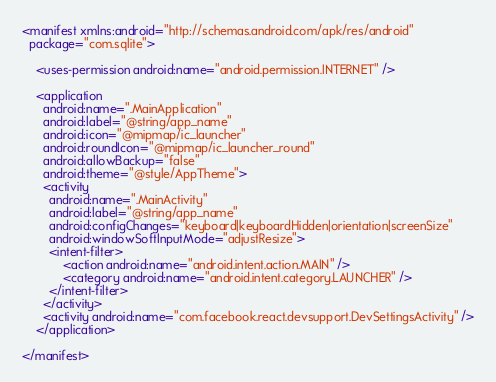Convert code to text. <code><loc_0><loc_0><loc_500><loc_500><_XML_><manifest xmlns:android="http://schemas.android.com/apk/res/android"
  package="com.sqlite">

    <uses-permission android:name="android.permission.INTERNET" />

    <application
      android:name=".MainApplication"
      android:label="@string/app_name"
      android:icon="@mipmap/ic_launcher"
      android:roundIcon="@mipmap/ic_launcher_round"
      android:allowBackup="false"
      android:theme="@style/AppTheme">
      <activity
        android:name=".MainActivity"
        android:label="@string/app_name"
        android:configChanges="keyboard|keyboardHidden|orientation|screenSize"
        android:windowSoftInputMode="adjustResize">
        <intent-filter>
            <action android:name="android.intent.action.MAIN" />
            <category android:name="android.intent.category.LAUNCHER" />
        </intent-filter>
      </activity>
      <activity android:name="com.facebook.react.devsupport.DevSettingsActivity" />
    </application>

</manifest>
</code> 